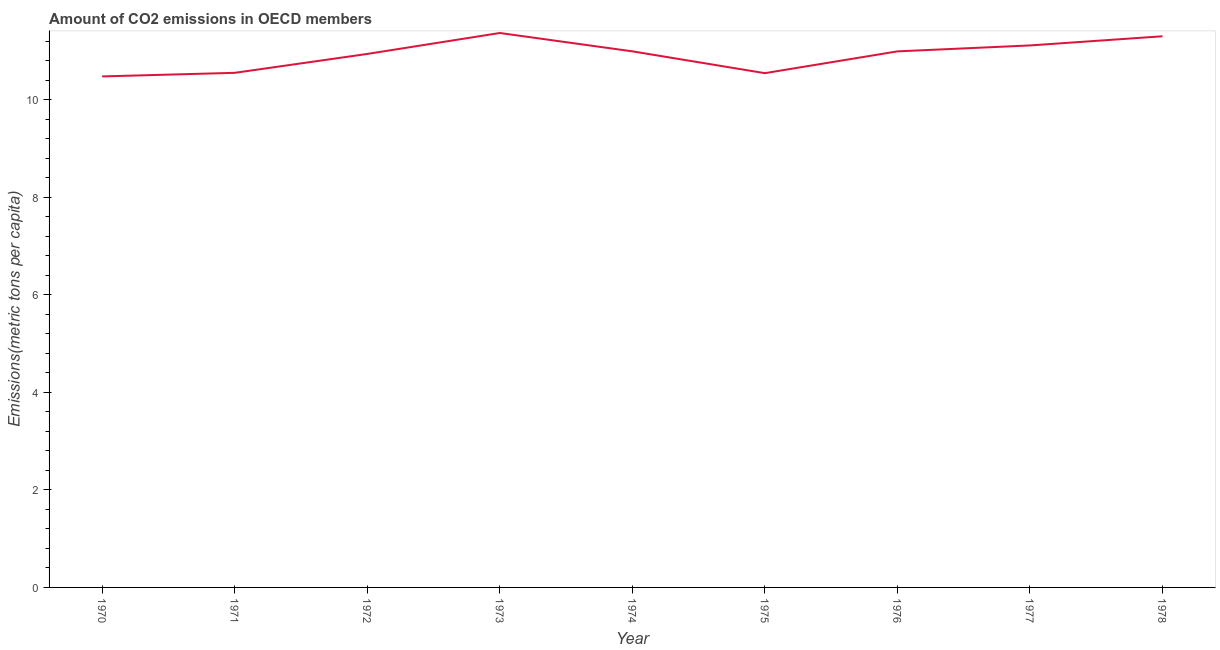What is the amount of co2 emissions in 1970?
Provide a succinct answer. 10.48. Across all years, what is the maximum amount of co2 emissions?
Give a very brief answer. 11.37. Across all years, what is the minimum amount of co2 emissions?
Give a very brief answer. 10.48. What is the sum of the amount of co2 emissions?
Provide a short and direct response. 98.29. What is the difference between the amount of co2 emissions in 1974 and 1975?
Offer a terse response. 0.45. What is the average amount of co2 emissions per year?
Your answer should be compact. 10.92. What is the median amount of co2 emissions?
Offer a very short reply. 10.99. In how many years, is the amount of co2 emissions greater than 8.8 metric tons per capita?
Make the answer very short. 9. What is the ratio of the amount of co2 emissions in 1972 to that in 1977?
Keep it short and to the point. 0.98. Is the difference between the amount of co2 emissions in 1974 and 1975 greater than the difference between any two years?
Provide a short and direct response. No. What is the difference between the highest and the second highest amount of co2 emissions?
Give a very brief answer. 0.07. What is the difference between the highest and the lowest amount of co2 emissions?
Your response must be concise. 0.89. Does the amount of co2 emissions monotonically increase over the years?
Your response must be concise. No. How many lines are there?
Keep it short and to the point. 1. What is the difference between two consecutive major ticks on the Y-axis?
Your response must be concise. 2. What is the title of the graph?
Your answer should be very brief. Amount of CO2 emissions in OECD members. What is the label or title of the Y-axis?
Give a very brief answer. Emissions(metric tons per capita). What is the Emissions(metric tons per capita) of 1970?
Your response must be concise. 10.48. What is the Emissions(metric tons per capita) in 1971?
Your answer should be very brief. 10.55. What is the Emissions(metric tons per capita) of 1972?
Your answer should be compact. 10.94. What is the Emissions(metric tons per capita) in 1973?
Keep it short and to the point. 11.37. What is the Emissions(metric tons per capita) in 1974?
Your answer should be compact. 10.99. What is the Emissions(metric tons per capita) in 1975?
Keep it short and to the point. 10.55. What is the Emissions(metric tons per capita) of 1976?
Provide a short and direct response. 10.99. What is the Emissions(metric tons per capita) in 1977?
Make the answer very short. 11.11. What is the Emissions(metric tons per capita) in 1978?
Provide a short and direct response. 11.3. What is the difference between the Emissions(metric tons per capita) in 1970 and 1971?
Provide a succinct answer. -0.07. What is the difference between the Emissions(metric tons per capita) in 1970 and 1972?
Ensure brevity in your answer.  -0.46. What is the difference between the Emissions(metric tons per capita) in 1970 and 1973?
Offer a terse response. -0.89. What is the difference between the Emissions(metric tons per capita) in 1970 and 1974?
Give a very brief answer. -0.51. What is the difference between the Emissions(metric tons per capita) in 1970 and 1975?
Your answer should be very brief. -0.07. What is the difference between the Emissions(metric tons per capita) in 1970 and 1976?
Provide a short and direct response. -0.51. What is the difference between the Emissions(metric tons per capita) in 1970 and 1977?
Give a very brief answer. -0.64. What is the difference between the Emissions(metric tons per capita) in 1970 and 1978?
Provide a short and direct response. -0.82. What is the difference between the Emissions(metric tons per capita) in 1971 and 1972?
Your answer should be compact. -0.39. What is the difference between the Emissions(metric tons per capita) in 1971 and 1973?
Your answer should be compact. -0.82. What is the difference between the Emissions(metric tons per capita) in 1971 and 1974?
Keep it short and to the point. -0.44. What is the difference between the Emissions(metric tons per capita) in 1971 and 1975?
Your response must be concise. 0.01. What is the difference between the Emissions(metric tons per capita) in 1971 and 1976?
Provide a short and direct response. -0.44. What is the difference between the Emissions(metric tons per capita) in 1971 and 1977?
Provide a short and direct response. -0.56. What is the difference between the Emissions(metric tons per capita) in 1971 and 1978?
Ensure brevity in your answer.  -0.75. What is the difference between the Emissions(metric tons per capita) in 1972 and 1973?
Provide a short and direct response. -0.43. What is the difference between the Emissions(metric tons per capita) in 1972 and 1974?
Offer a very short reply. -0.05. What is the difference between the Emissions(metric tons per capita) in 1972 and 1975?
Your answer should be compact. 0.39. What is the difference between the Emissions(metric tons per capita) in 1972 and 1976?
Give a very brief answer. -0.05. What is the difference between the Emissions(metric tons per capita) in 1972 and 1977?
Your answer should be very brief. -0.17. What is the difference between the Emissions(metric tons per capita) in 1972 and 1978?
Offer a terse response. -0.36. What is the difference between the Emissions(metric tons per capita) in 1973 and 1974?
Provide a short and direct response. 0.38. What is the difference between the Emissions(metric tons per capita) in 1973 and 1975?
Provide a succinct answer. 0.82. What is the difference between the Emissions(metric tons per capita) in 1973 and 1976?
Make the answer very short. 0.38. What is the difference between the Emissions(metric tons per capita) in 1973 and 1977?
Give a very brief answer. 0.26. What is the difference between the Emissions(metric tons per capita) in 1973 and 1978?
Offer a very short reply. 0.07. What is the difference between the Emissions(metric tons per capita) in 1974 and 1975?
Ensure brevity in your answer.  0.45. What is the difference between the Emissions(metric tons per capita) in 1974 and 1976?
Offer a terse response. 0. What is the difference between the Emissions(metric tons per capita) in 1974 and 1977?
Offer a terse response. -0.12. What is the difference between the Emissions(metric tons per capita) in 1974 and 1978?
Offer a very short reply. -0.31. What is the difference between the Emissions(metric tons per capita) in 1975 and 1976?
Keep it short and to the point. -0.45. What is the difference between the Emissions(metric tons per capita) in 1975 and 1977?
Make the answer very short. -0.57. What is the difference between the Emissions(metric tons per capita) in 1975 and 1978?
Make the answer very short. -0.76. What is the difference between the Emissions(metric tons per capita) in 1976 and 1977?
Provide a short and direct response. -0.12. What is the difference between the Emissions(metric tons per capita) in 1976 and 1978?
Ensure brevity in your answer.  -0.31. What is the difference between the Emissions(metric tons per capita) in 1977 and 1978?
Give a very brief answer. -0.19. What is the ratio of the Emissions(metric tons per capita) in 1970 to that in 1972?
Your response must be concise. 0.96. What is the ratio of the Emissions(metric tons per capita) in 1970 to that in 1973?
Provide a succinct answer. 0.92. What is the ratio of the Emissions(metric tons per capita) in 1970 to that in 1974?
Give a very brief answer. 0.95. What is the ratio of the Emissions(metric tons per capita) in 1970 to that in 1975?
Offer a terse response. 0.99. What is the ratio of the Emissions(metric tons per capita) in 1970 to that in 1976?
Keep it short and to the point. 0.95. What is the ratio of the Emissions(metric tons per capita) in 1970 to that in 1977?
Make the answer very short. 0.94. What is the ratio of the Emissions(metric tons per capita) in 1970 to that in 1978?
Your response must be concise. 0.93. What is the ratio of the Emissions(metric tons per capita) in 1971 to that in 1972?
Ensure brevity in your answer.  0.96. What is the ratio of the Emissions(metric tons per capita) in 1971 to that in 1973?
Ensure brevity in your answer.  0.93. What is the ratio of the Emissions(metric tons per capita) in 1971 to that in 1974?
Provide a succinct answer. 0.96. What is the ratio of the Emissions(metric tons per capita) in 1971 to that in 1977?
Keep it short and to the point. 0.95. What is the ratio of the Emissions(metric tons per capita) in 1971 to that in 1978?
Your answer should be compact. 0.93. What is the ratio of the Emissions(metric tons per capita) in 1972 to that in 1973?
Ensure brevity in your answer.  0.96. What is the ratio of the Emissions(metric tons per capita) in 1972 to that in 1974?
Ensure brevity in your answer.  0.99. What is the ratio of the Emissions(metric tons per capita) in 1972 to that in 1976?
Ensure brevity in your answer.  0.99. What is the ratio of the Emissions(metric tons per capita) in 1972 to that in 1977?
Make the answer very short. 0.98. What is the ratio of the Emissions(metric tons per capita) in 1972 to that in 1978?
Provide a short and direct response. 0.97. What is the ratio of the Emissions(metric tons per capita) in 1973 to that in 1974?
Give a very brief answer. 1.03. What is the ratio of the Emissions(metric tons per capita) in 1973 to that in 1975?
Your response must be concise. 1.08. What is the ratio of the Emissions(metric tons per capita) in 1973 to that in 1976?
Provide a short and direct response. 1.03. What is the ratio of the Emissions(metric tons per capita) in 1973 to that in 1977?
Provide a short and direct response. 1.02. What is the ratio of the Emissions(metric tons per capita) in 1973 to that in 1978?
Offer a terse response. 1.01. What is the ratio of the Emissions(metric tons per capita) in 1974 to that in 1975?
Provide a succinct answer. 1.04. What is the ratio of the Emissions(metric tons per capita) in 1975 to that in 1976?
Ensure brevity in your answer.  0.96. What is the ratio of the Emissions(metric tons per capita) in 1975 to that in 1977?
Offer a terse response. 0.95. What is the ratio of the Emissions(metric tons per capita) in 1975 to that in 1978?
Your response must be concise. 0.93. What is the ratio of the Emissions(metric tons per capita) in 1976 to that in 1977?
Keep it short and to the point. 0.99. What is the ratio of the Emissions(metric tons per capita) in 1976 to that in 1978?
Ensure brevity in your answer.  0.97. What is the ratio of the Emissions(metric tons per capita) in 1977 to that in 1978?
Ensure brevity in your answer.  0.98. 